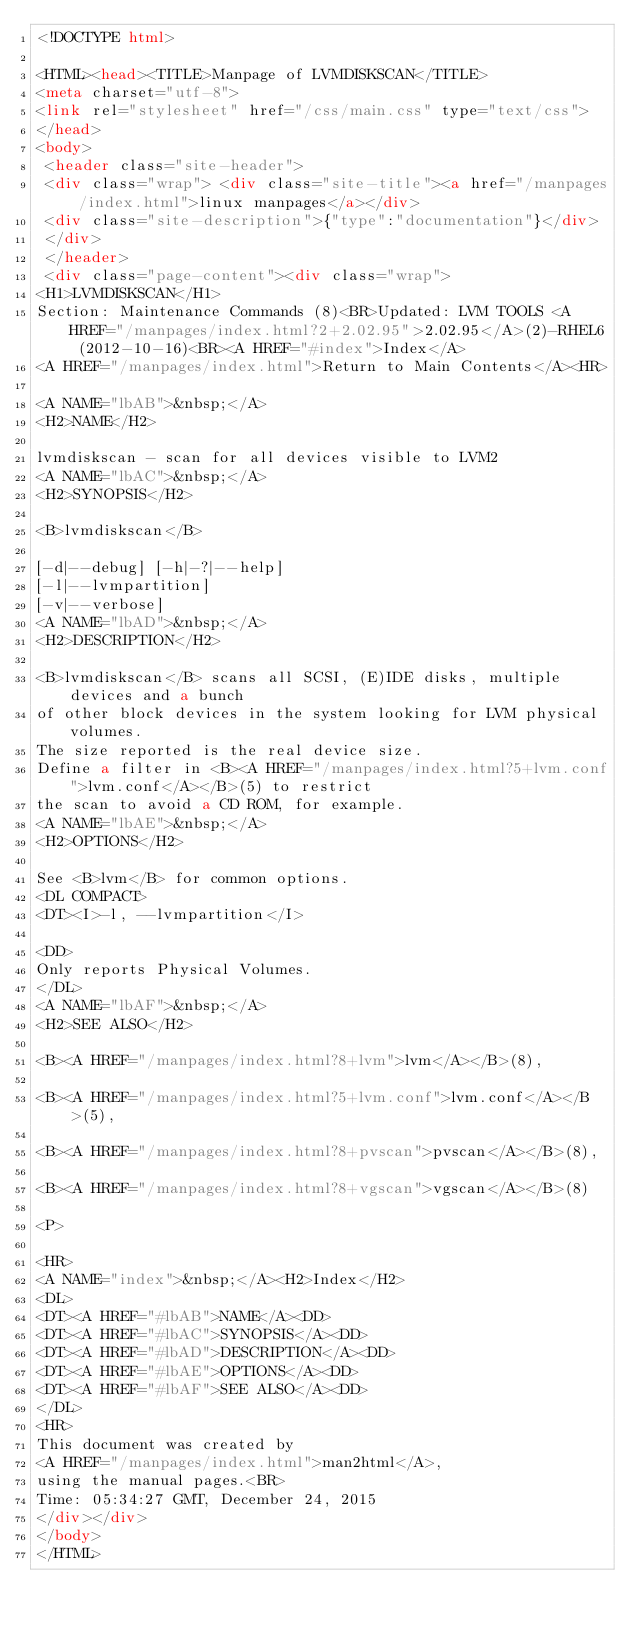<code> <loc_0><loc_0><loc_500><loc_500><_HTML_><!DOCTYPE html>

<HTML><head><TITLE>Manpage of LVMDISKSCAN</TITLE>
<meta charset="utf-8">
<link rel="stylesheet" href="/css/main.css" type="text/css">
</head>
<body>
 <header class="site-header">
 <div class="wrap"> <div class="site-title"><a href="/manpages/index.html">linux manpages</a></div>
 <div class="site-description">{"type":"documentation"}</div>
 </div>
 </header>
 <div class="page-content"><div class="wrap">
<H1>LVMDISKSCAN</H1>
Section: Maintenance Commands (8)<BR>Updated: LVM TOOLS <A HREF="/manpages/index.html?2+2.02.95">2.02.95</A>(2)-RHEL6 (2012-10-16)<BR><A HREF="#index">Index</A>
<A HREF="/manpages/index.html">Return to Main Contents</A><HR>

<A NAME="lbAB">&nbsp;</A>
<H2>NAME</H2>

lvmdiskscan - scan for all devices visible to LVM2
<A NAME="lbAC">&nbsp;</A>
<H2>SYNOPSIS</H2>

<B>lvmdiskscan</B>

[-d|--debug] [-h|-?|--help] 
[-l|--lvmpartition]
[-v|--verbose]
<A NAME="lbAD">&nbsp;</A>
<H2>DESCRIPTION</H2>

<B>lvmdiskscan</B> scans all SCSI, (E)IDE disks, multiple devices and a bunch
of other block devices in the system looking for LVM physical volumes.
The size reported is the real device size.
Define a filter in <B><A HREF="/manpages/index.html?5+lvm.conf">lvm.conf</A></B>(5) to restrict 
the scan to avoid a CD ROM, for example.
<A NAME="lbAE">&nbsp;</A>
<H2>OPTIONS</H2>

See <B>lvm</B> for common options.
<DL COMPACT>
<DT><I>-l, --lvmpartition</I>

<DD>
Only reports Physical Volumes.
</DL>
<A NAME="lbAF">&nbsp;</A>
<H2>SEE ALSO</H2>

<B><A HREF="/manpages/index.html?8+lvm">lvm</A></B>(8),

<B><A HREF="/manpages/index.html?5+lvm.conf">lvm.conf</A></B>(5),

<B><A HREF="/manpages/index.html?8+pvscan">pvscan</A></B>(8),

<B><A HREF="/manpages/index.html?8+vgscan">vgscan</A></B>(8)

<P>

<HR>
<A NAME="index">&nbsp;</A><H2>Index</H2>
<DL>
<DT><A HREF="#lbAB">NAME</A><DD>
<DT><A HREF="#lbAC">SYNOPSIS</A><DD>
<DT><A HREF="#lbAD">DESCRIPTION</A><DD>
<DT><A HREF="#lbAE">OPTIONS</A><DD>
<DT><A HREF="#lbAF">SEE ALSO</A><DD>
</DL>
<HR>
This document was created by
<A HREF="/manpages/index.html">man2html</A>,
using the manual pages.<BR>
Time: 05:34:27 GMT, December 24, 2015
</div></div>
</body>
</HTML>
</code> 